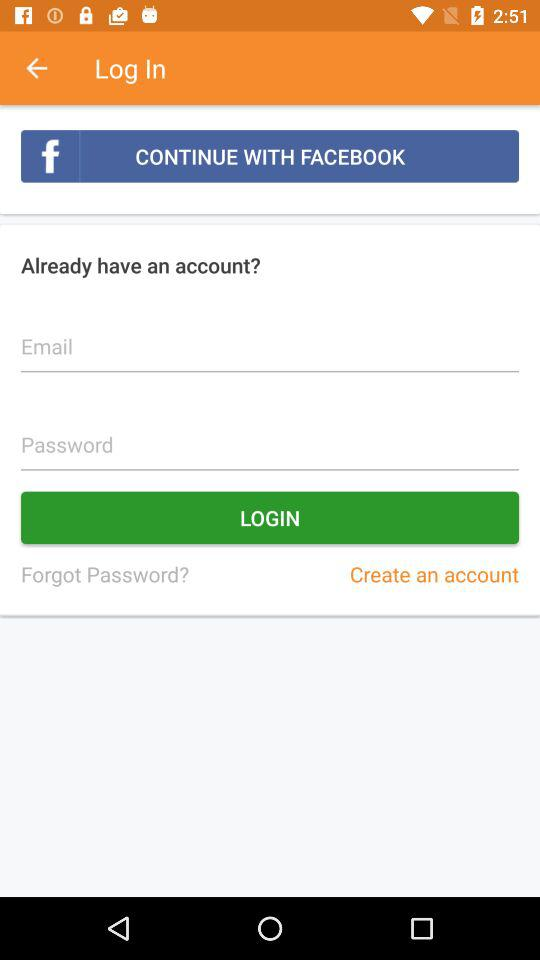What is the entered email address?
When the provided information is insufficient, respond with <no answer>. <no answer> 